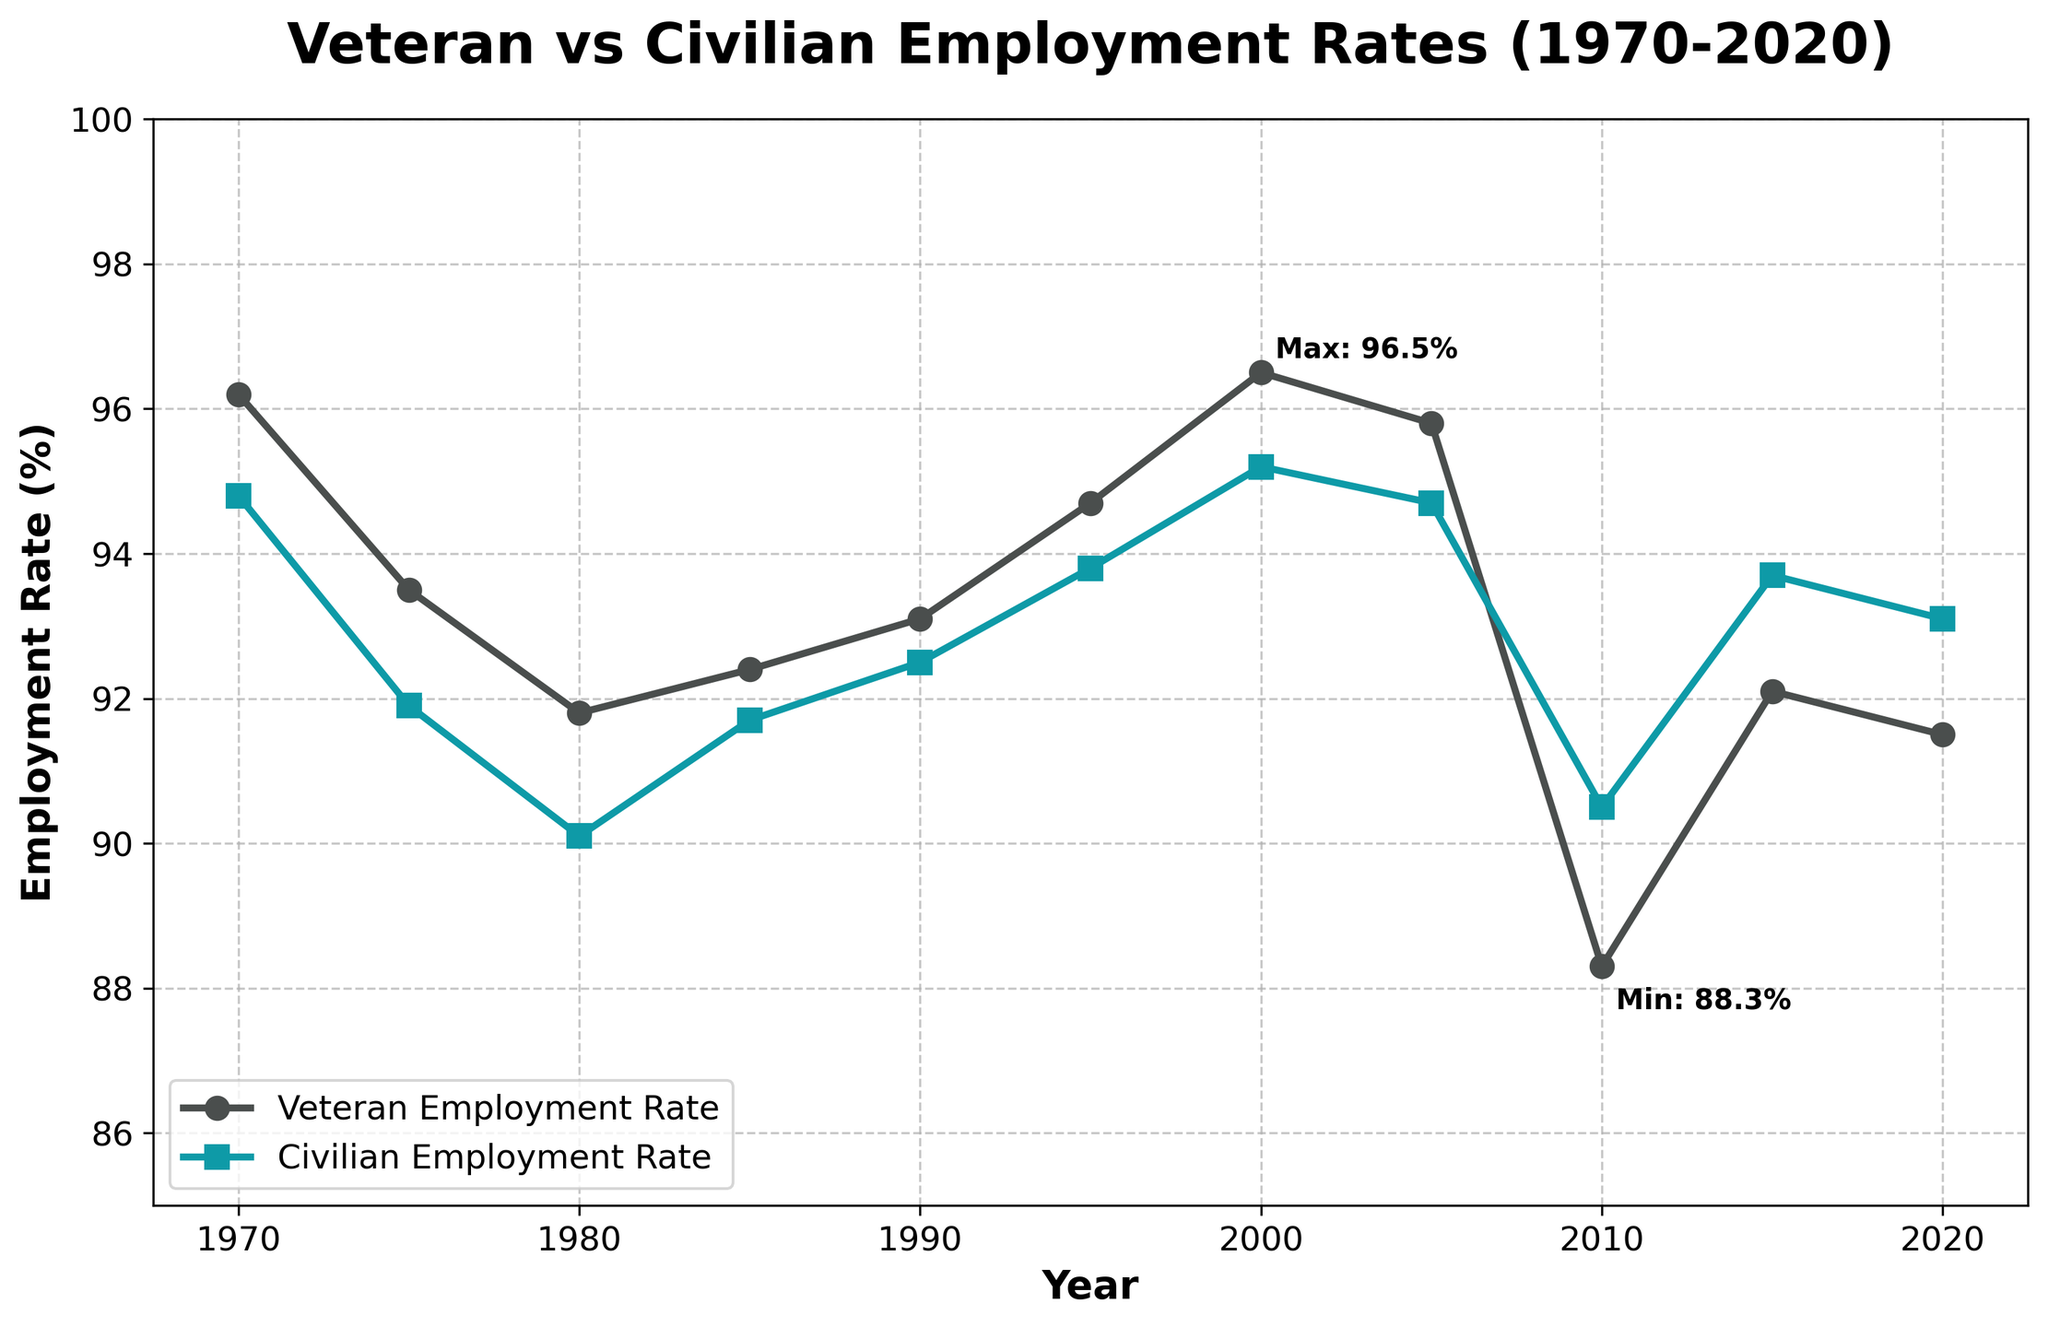Which year had the highest veteran employment rate? The highest veteran employment rate can be identified by looking for the peak point in the trend line for veteran employment rates. This year is annotated as "Max" on the chart.
Answer: 2000 Which year had the lowest veteran employment rate? The lowest veteran employment rate can be identified by looking for the lowest point in the trend line for veteran employment rates. This year is annotated as "Min" on the chart.
Answer: 2010 By how much did the veteran employment rate decrease from 1970 to 2010? Subtract the veteran employment rate in 2010 from the rate in 1970. 96.2% in 1970 minus 88.3% in 2010 gives 96.2% - 88.3%.
Answer: 7.9% Was there any year when the civilian employment rate was higher than the veteran employment rate? Compare both lines on the plot for any intersection points or instances where the civilian employment rate line is visually higher than the veteran employment rate line. The year 2010 shows the civilian employment rate was 90.5% and veteran's was 88.3%.
Answer: Yes, in 2010 On average, how much higher was the veteran employment rate than the civilian employment rate over the 50-year period? First, calculate the differences for each year, sum them up, and then divide by the number of years. For each year: (96.2-94.8), (93.5-91.9), (91.8-90.1), (92.4-91.7), (93.1-92.5), (94.7-93.8), (96.5-95.2), (95.8-94.7), (88.3-90.5), (92.1-93.7), (91.5-93.1). Sum: 1.4+1.6+1.7+0.7+0.6+0.9+1.3+1.1+(-2.2)+(-1.6)+(-1.6) = 2.9. Average: 2.9 / 11.
Answer: 0.26% In which decade was the veteran employment rate the most stable, showing the least fluctuation? Identify the decade where the veteran employment rate line shows the smallest range of changes, i.e., the smoothest line over a 10-year period. The 1990s show minor fluctuations between 1990, 1995, and 2000.
Answer: 1990s Between 1980 and 2000, how did the veteran employment rate change compared to the civilian employment rate? Compare the change in veteran employment rates and civilian employment rates from 1980 to 2000 by calculating the differences for both: Veteran rate changes (96.5% - 91.8%), Civilian rate changes (95.2% - 90.1%).
Answer: Veterans: +4.7%, Civilians: +5.1% Which employment rate had the higher maximum value, veteran or civilian? Identify the maximum value for each employment rate and compare them. The graph shows maximum annotations, where the veteran's max is 96.5% and the civilian's max is 95.2%.
Answer: Veteran During which periods did the veteran employment rate show a noticeable drop, and how did it affect the relative position compared to the civilian employment rate? Examine the trend line of veteran employment rates for periods of sharp decline, particularly looking at 2005 to 2010. Also, note how the civilian rate changed relative to this. The veteran rate dropped noticeably from 95.8% in 2005 to 88.3% in 2010.
Answer: 2005-2010 What was the overall trend for both veteran and civilian employment rates from 1970 to 2020? Evaluate the general direction and changes in both trend lines over the entire period. The veteran employment rate starts high, declines steeply, slightly recovers, and declines again, while the civilian rate shows gradual improvement.
Answer: Veterans: Decreasing, Civilians: Increasing Did the employment rates for both veterans and civilians converge or diverge over the 50-year period? Observe if the lines for veteran and civilian employment rates get closer (converge) or further apart (diverge) over time. While both lines fluctuate, by 2020, the gap between the two has narrowed compared to the 1970s.
Answer: Converge 